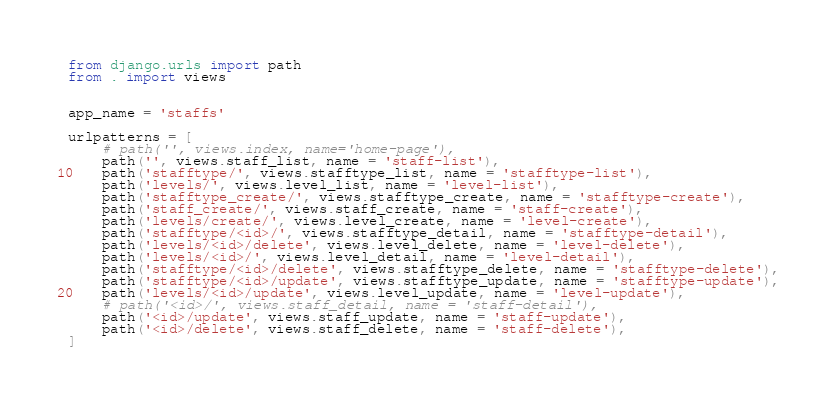<code> <loc_0><loc_0><loc_500><loc_500><_Python_>from django.urls import path
from . import views


app_name = 'staffs'

urlpatterns = [
    # path('', views.index, name='home-page'),
    path('', views.staff_list, name = 'staff-list'),
    path('stafftype/', views.stafftype_list, name = 'stafftype-list'),
    path('levels/', views.level_list, name = 'level-list'),
    path('stafftype_create/', views.stafftype_create, name = 'stafftype-create'),
    path('staff_create/', views.staff_create, name = 'staff-create'),
    path('levels/create/', views.level_create, name = 'level-create'),
    path('stafftype/<id>/', views.stafftype_detail, name = 'stafftype-detail'),
    path('levels/<id>/delete', views.level_delete, name = 'level-delete'),
    path('levels/<id>/', views.level_detail, name = 'level-detail'),
    path('stafftype/<id>/delete', views.stafftype_delete, name = 'stafftype-delete'),
    path('stafftype/<id>/update', views.stafftype_update, name = 'stafftype-update'),
    path('levels/<id>/update', views.level_update, name = 'level-update'),
    # path('<id>/', views.staff_detail, name = 'staff-detail'),
    path('<id>/update', views.staff_update, name = 'staff-update'),
    path('<id>/delete', views.staff_delete, name = 'staff-delete'),
]

</code> 